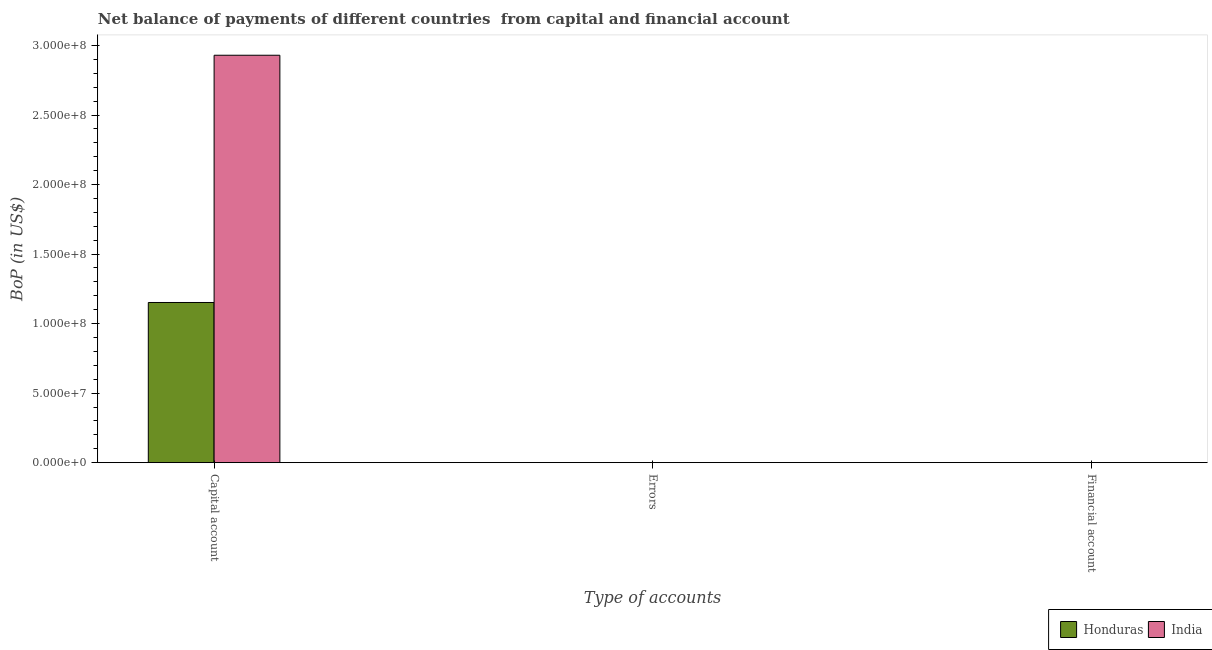How many different coloured bars are there?
Give a very brief answer. 2. What is the label of the 1st group of bars from the left?
Offer a very short reply. Capital account. What is the amount of errors in India?
Ensure brevity in your answer.  0. Across all countries, what is the maximum amount of net capital account?
Provide a succinct answer. 2.93e+08. Across all countries, what is the minimum amount of errors?
Your answer should be compact. 0. What is the total amount of errors in the graph?
Your answer should be compact. 0. What is the difference between the amount of net capital account in India and that in Honduras?
Make the answer very short. 1.78e+08. In how many countries, is the amount of net capital account greater than 80000000 US$?
Provide a short and direct response. 2. What is the ratio of the amount of net capital account in India to that in Honduras?
Give a very brief answer. 2.54. Is the amount of net capital account in Honduras less than that in India?
Your response must be concise. Yes. What is the difference between the highest and the second highest amount of net capital account?
Your answer should be very brief. 1.78e+08. In how many countries, is the amount of errors greater than the average amount of errors taken over all countries?
Your answer should be very brief. 0. Is the sum of the amount of net capital account in Honduras and India greater than the maximum amount of errors across all countries?
Offer a very short reply. Yes. Is it the case that in every country, the sum of the amount of net capital account and amount of errors is greater than the amount of financial account?
Make the answer very short. Yes. How many bars are there?
Your answer should be compact. 2. What is the difference between two consecutive major ticks on the Y-axis?
Provide a succinct answer. 5.00e+07. Does the graph contain any zero values?
Provide a succinct answer. Yes. What is the title of the graph?
Ensure brevity in your answer.  Net balance of payments of different countries  from capital and financial account. What is the label or title of the X-axis?
Give a very brief answer. Type of accounts. What is the label or title of the Y-axis?
Provide a succinct answer. BoP (in US$). What is the BoP (in US$) in Honduras in Capital account?
Provide a short and direct response. 1.15e+08. What is the BoP (in US$) of India in Capital account?
Provide a succinct answer. 2.93e+08. What is the BoP (in US$) in India in Errors?
Provide a short and direct response. 0. What is the BoP (in US$) of India in Financial account?
Your response must be concise. 0. Across all Type of accounts, what is the maximum BoP (in US$) in Honduras?
Offer a terse response. 1.15e+08. Across all Type of accounts, what is the maximum BoP (in US$) in India?
Your response must be concise. 2.93e+08. Across all Type of accounts, what is the minimum BoP (in US$) of Honduras?
Your response must be concise. 0. What is the total BoP (in US$) in Honduras in the graph?
Offer a terse response. 1.15e+08. What is the total BoP (in US$) in India in the graph?
Offer a very short reply. 2.93e+08. What is the average BoP (in US$) of Honduras per Type of accounts?
Give a very brief answer. 3.84e+07. What is the average BoP (in US$) of India per Type of accounts?
Ensure brevity in your answer.  9.77e+07. What is the difference between the BoP (in US$) of Honduras and BoP (in US$) of India in Capital account?
Give a very brief answer. -1.78e+08. What is the difference between the highest and the lowest BoP (in US$) in Honduras?
Your answer should be very brief. 1.15e+08. What is the difference between the highest and the lowest BoP (in US$) of India?
Offer a terse response. 2.93e+08. 